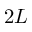Convert formula to latex. <formula><loc_0><loc_0><loc_500><loc_500>2 L</formula> 